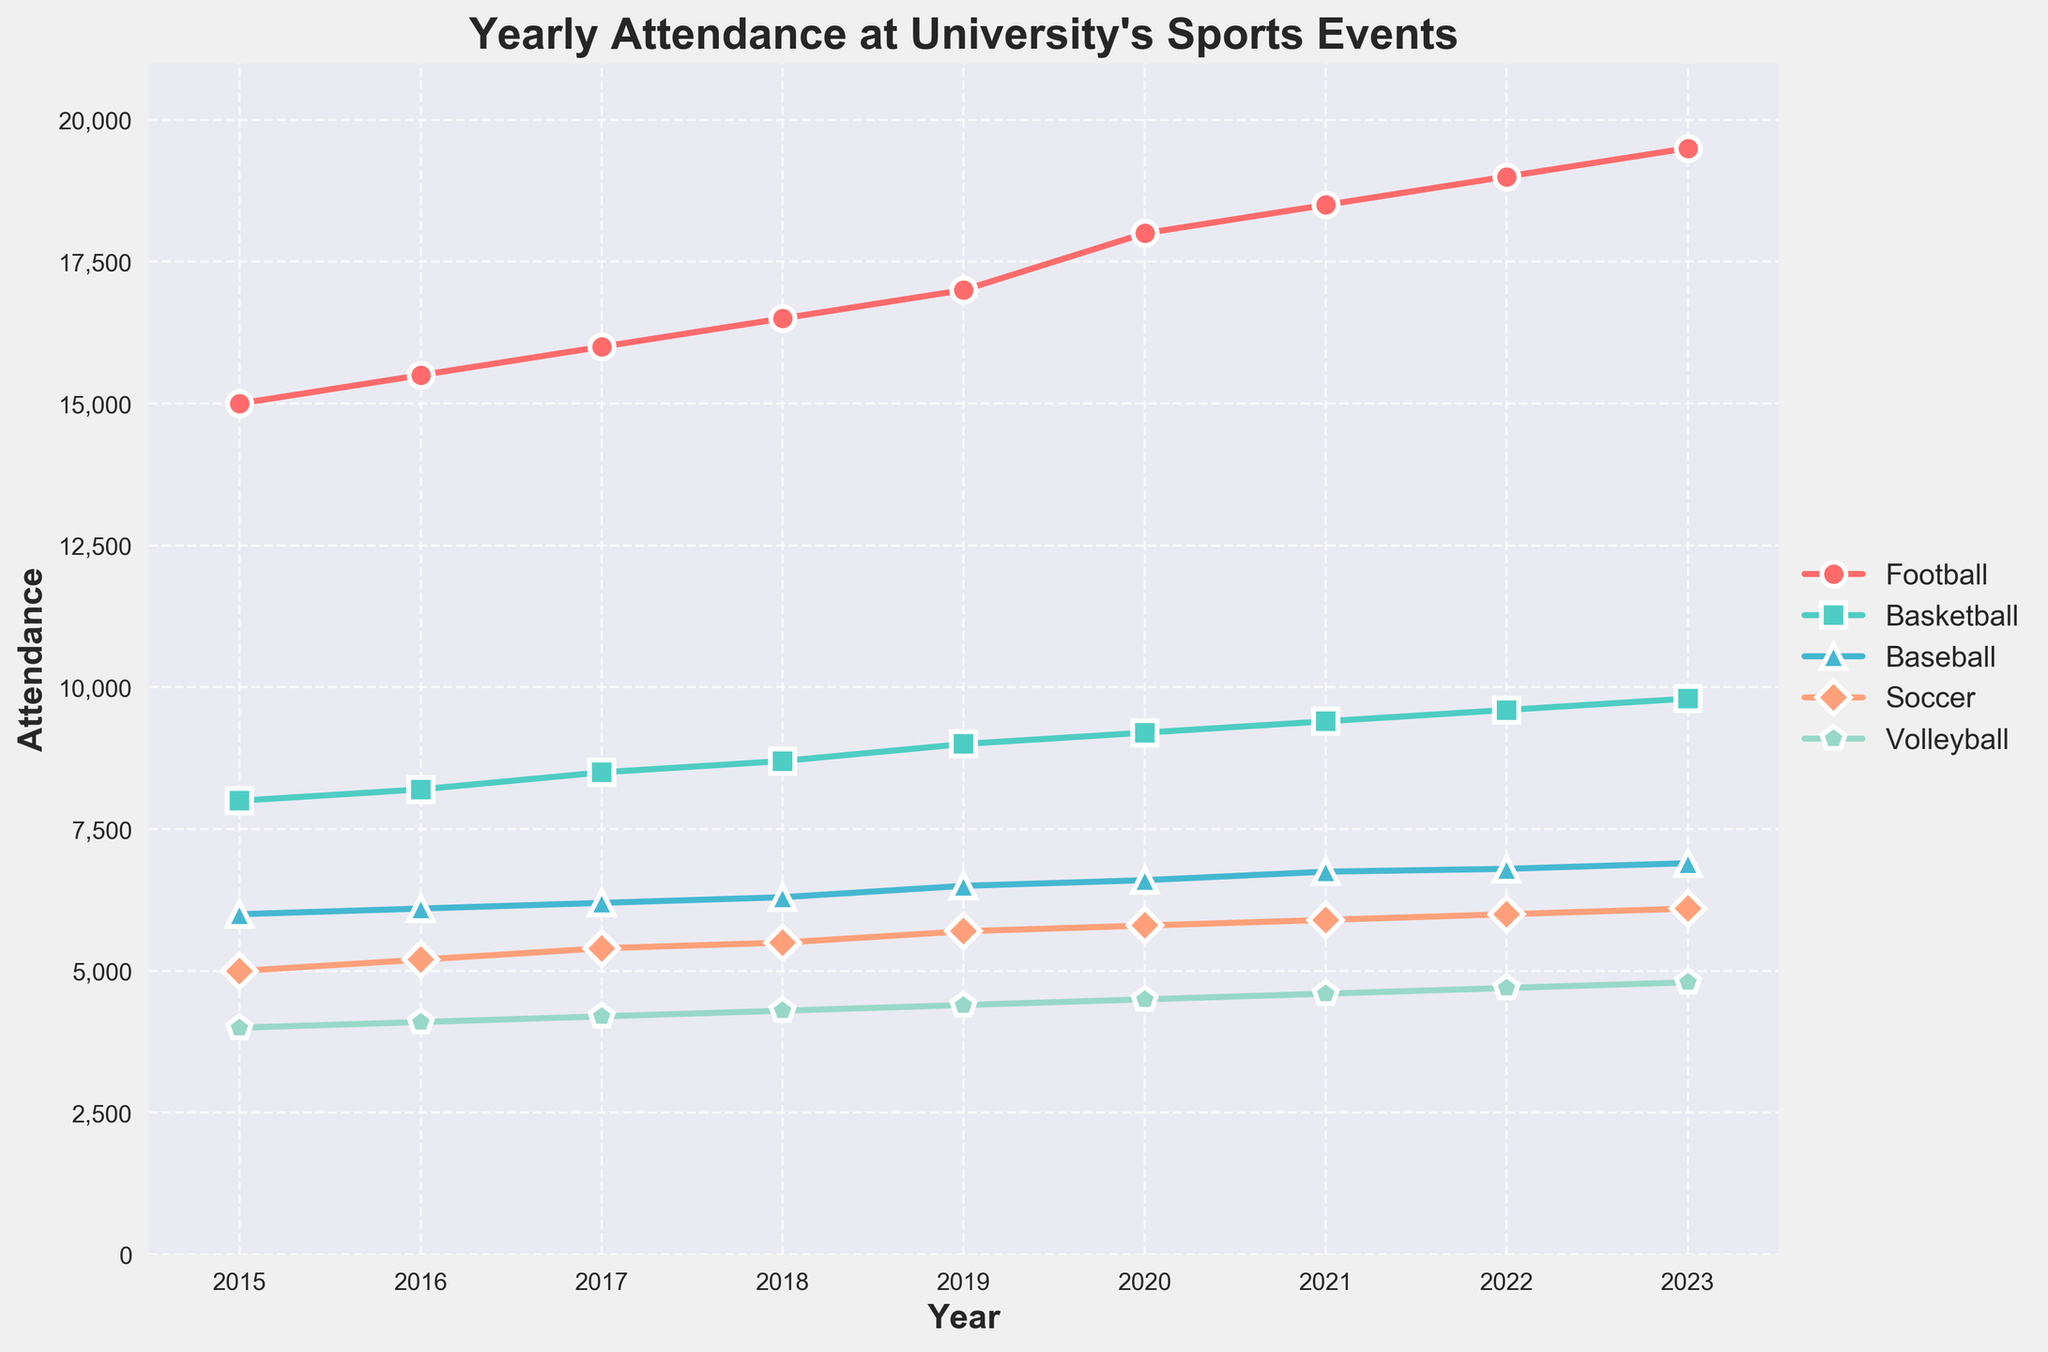What's the title of the plot? The title is written at the top center of the plot.
Answer: Yearly Attendance at University's Sports Events What is the attendance for Football in 2018? Look at the intersection of the year 2018 on the x-axis and the Football line.
Answer: 16500 How many sports are represented in the figure? Count the distinct lines, each representing a sport, in the plot.
Answer: 5 Which sport had the highest attendance in any year, and in what year? Look for the line that reaches the highest point on the y-axis and identify the corresponding year.
Answer: Football, 2023 By how much did Soccer attendance increase from 2015 to 2023? Subtract the Soccer attendance in 2015 from the attendance in 2023: 6100 - 5000.
Answer: 1100 What is the trend for Volleyball attendance from 2015 to 2023? Observe the Volleyball line from 2015 to 2023.
Answer: Increasing Which year marked the highest attendance for Basketball? Locate the peak of the Basketball line and check the corresponding year on the x-axis.
Answer: 2023 Compare the attendance growth of Baseball and Soccer from 2015 to 2023. Which one grew more? Calculate the increase for both sports: Baseball (6900 - 6000) = 900, Soccer (6100 - 5000) = 1100. Compare the two increases.
Answer: Soccer What are the markers used for each sport in the plot? Identify the shapes used for each sport line in the figure legend.
Answer: Football (circle), Basketball (square), Baseball (triangle), Soccer (diamond), Volleyball (pentagon) What is the average attendance across all sports in 2023? Sum the 2023 attendance for all sports and divide by the number of sports: (19500 + 9800 + 6900 + 6100 + 4800) / 5.
Answer: 9420 In which year did all sports see an increase in attendance compared to the previous year? Check each year and compare the attendance of each sport to the previous year.
Answer: Every year from 2015 to 2023 